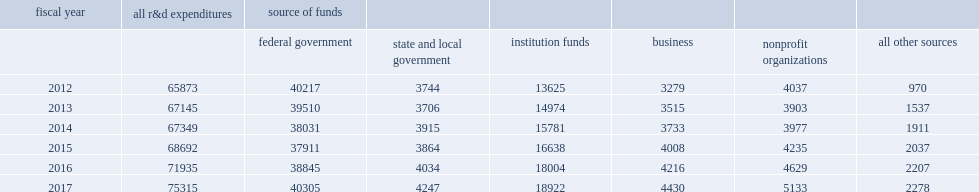How many million dollars did total r&d expenditures reach in fy 2017? 75315.0. How many million dollars did total r&d expenditures reach in fy 2016? 71935.0. 